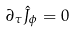<formula> <loc_0><loc_0><loc_500><loc_500>\partial _ { \tau } \hat { J } _ { \phi } = 0</formula> 